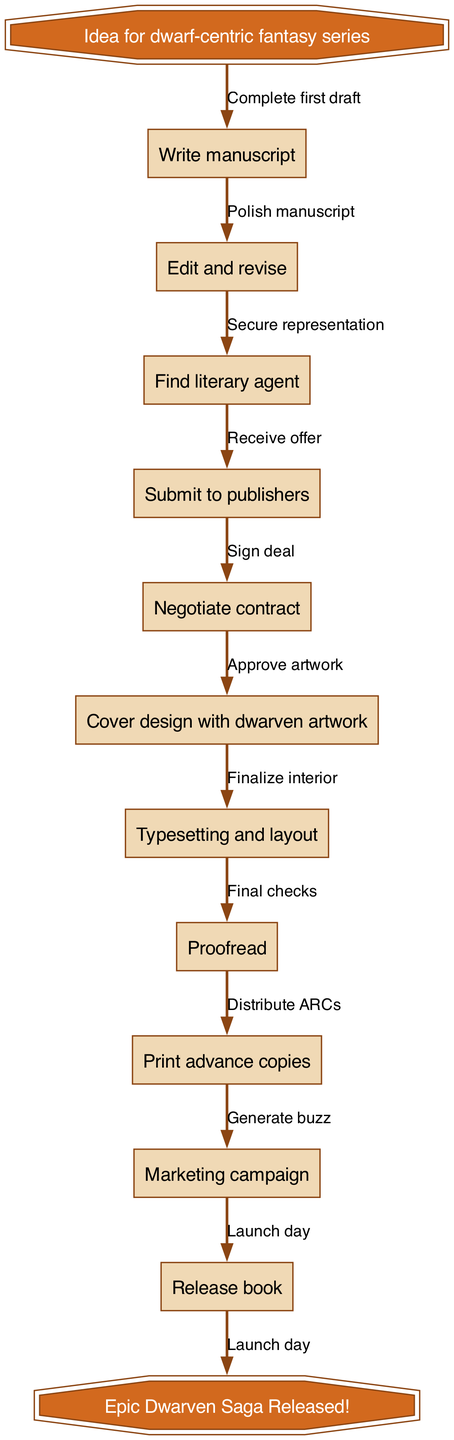What is the starting point of the publishing process? The diagram indicates that the starting point is the "Idea for dwarf-centric fantasy series." This is the first node in the flowchart and serves as the initiation of the whole process.
Answer: Idea for dwarf-centric fantasy series How many nodes are present in the diagram? Counting the nodes listed in the diagram, there are 10 specific process nodes, including the start and end nodes. Therefore, I add the start and end nodes to the total, resulting in 12 nodes.
Answer: 12 What is the first major action in the process? The diagram shows that the first major action taken once the idea is conceived is to "Write manuscript." This is the first step that follows the initial idea in the flowchart.
Answer: Write manuscript What happens after "Proofread"? From the diagram, the next step after "Proofread" is "Print advance copies." This follows the proofreading step, indicating that after the manuscript is checked for errors, the next action is preparation for printing.
Answer: Print advance copies What type of artwork is used for cover design? The diagram specifies "Cover design with dwarven artwork" as part of the publishing process. This indicates that the artwork theme for the cover explicitly relates to dwarves, aligning with the series' fantasy genre.
Answer: dwarven artwork How many edges are there in the diagram? To find the number of edges, count the connections between the nodes. Each edge represents a step from one node to the next, totaling 11 edges based on the connections in the diagram.
Answer: 11 What is the final outcome of the process? At the end of the flowchart, the outcome is stated as "Epic Dwarven Saga Released!" This is the final node after all steps are completed, indicating the successful launch of the book series.
Answer: Epic Dwarven Saga Released! What step occurs directly before the launch day? Looking at the diagram, the step that comes immediately before the "Launch day" is "Generate buzz." This implies that marketing efforts to create excitement are essential right before the official release.
Answer: Generate buzz How many steps do you have to go through before "Negotiate contract"? In the flow, "Negotiate contract" is the 5th step. Therefore, you must go through 4 previous steps to reach it, including manuscript writing, editing, finding an agent, and submitting to publishers.
Answer: 4 